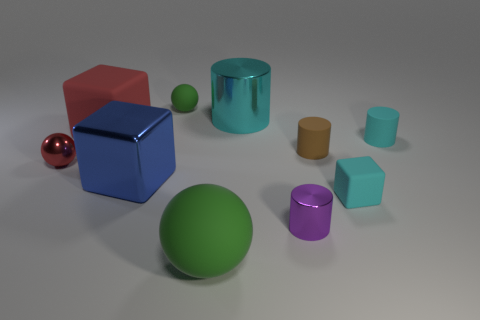Subtract all green cylinders. Subtract all purple balls. How many cylinders are left? 4 Subtract all cubes. How many objects are left? 7 Add 3 large cyan metallic cylinders. How many large cyan metallic cylinders are left? 4 Add 8 small cyan objects. How many small cyan objects exist? 10 Subtract 0 green cylinders. How many objects are left? 10 Subtract all small brown matte cylinders. Subtract all large blue metallic blocks. How many objects are left? 8 